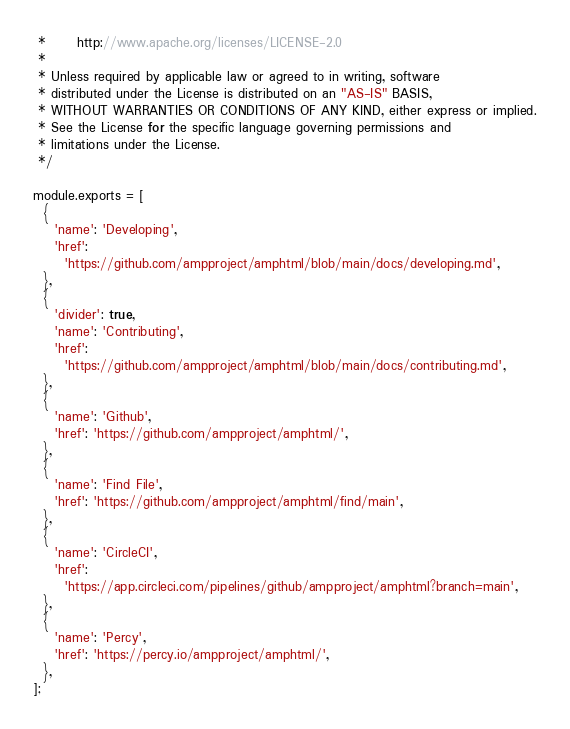Convert code to text. <code><loc_0><loc_0><loc_500><loc_500><_JavaScript_> *      http://www.apache.org/licenses/LICENSE-2.0
 *
 * Unless required by applicable law or agreed to in writing, software
 * distributed under the License is distributed on an "AS-IS" BASIS,
 * WITHOUT WARRANTIES OR CONDITIONS OF ANY KIND, either express or implied.
 * See the License for the specific language governing permissions and
 * limitations under the License.
 */

module.exports = [
  {
    'name': 'Developing',
    'href':
      'https://github.com/ampproject/amphtml/blob/main/docs/developing.md',
  },
  {
    'divider': true,
    'name': 'Contributing',
    'href':
      'https://github.com/ampproject/amphtml/blob/main/docs/contributing.md',
  },
  {
    'name': 'Github',
    'href': 'https://github.com/ampproject/amphtml/',
  },
  {
    'name': 'Find File',
    'href': 'https://github.com/ampproject/amphtml/find/main',
  },
  {
    'name': 'CircleCI',
    'href':
      'https://app.circleci.com/pipelines/github/ampproject/amphtml?branch=main',
  },
  {
    'name': 'Percy',
    'href': 'https://percy.io/ampproject/amphtml/',
  },
];
</code> 